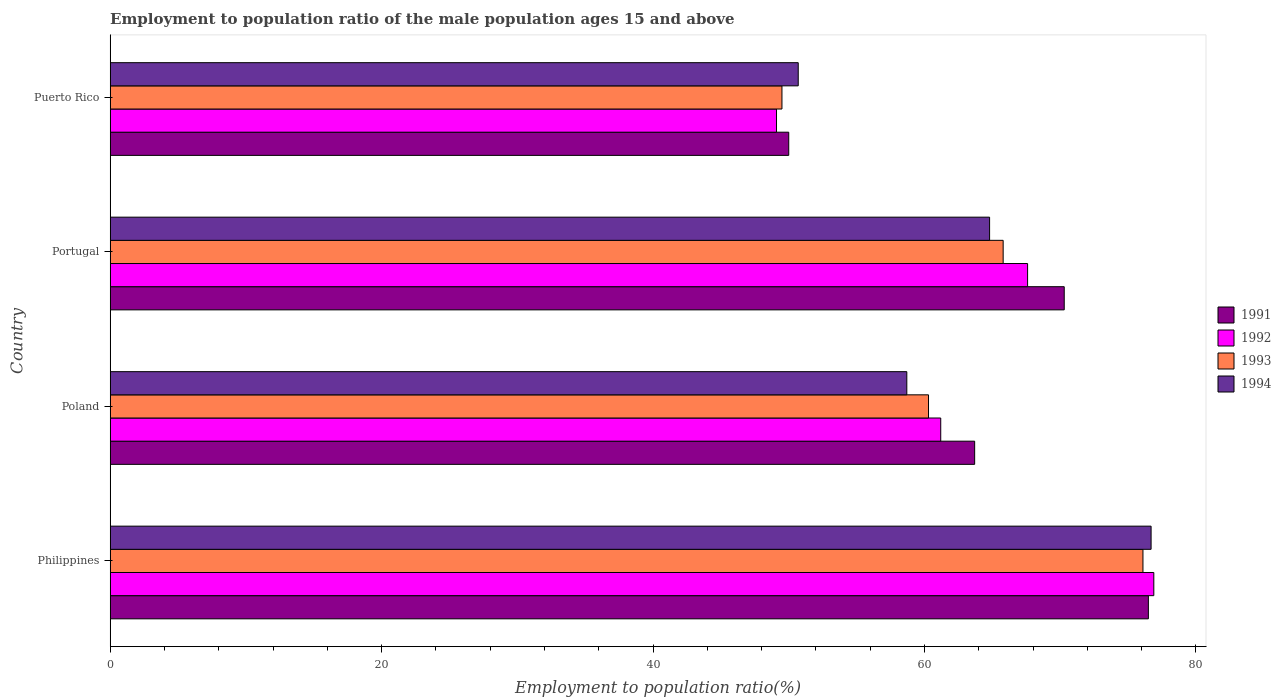Are the number of bars on each tick of the Y-axis equal?
Provide a succinct answer. Yes. In how many cases, is the number of bars for a given country not equal to the number of legend labels?
Offer a terse response. 0. What is the employment to population ratio in 1994 in Poland?
Give a very brief answer. 58.7. Across all countries, what is the maximum employment to population ratio in 1994?
Your response must be concise. 76.7. Across all countries, what is the minimum employment to population ratio in 1992?
Your answer should be compact. 49.1. In which country was the employment to population ratio in 1994 minimum?
Make the answer very short. Puerto Rico. What is the total employment to population ratio in 1992 in the graph?
Provide a short and direct response. 254.8. What is the difference between the employment to population ratio in 1993 in Poland and the employment to population ratio in 1991 in Portugal?
Offer a terse response. -10. What is the average employment to population ratio in 1994 per country?
Give a very brief answer. 62.73. What is the difference between the employment to population ratio in 1992 and employment to population ratio in 1993 in Portugal?
Make the answer very short. 1.8. In how many countries, is the employment to population ratio in 1991 greater than 16 %?
Make the answer very short. 4. What is the ratio of the employment to population ratio in 1994 in Portugal to that in Puerto Rico?
Make the answer very short. 1.28. Is the employment to population ratio in 1991 in Poland less than that in Portugal?
Provide a succinct answer. Yes. What is the difference between the highest and the second highest employment to population ratio in 1992?
Ensure brevity in your answer.  9.3. What is the difference between the highest and the lowest employment to population ratio in 1994?
Provide a short and direct response. 26. In how many countries, is the employment to population ratio in 1991 greater than the average employment to population ratio in 1991 taken over all countries?
Keep it short and to the point. 2. Are all the bars in the graph horizontal?
Give a very brief answer. Yes. How many countries are there in the graph?
Offer a very short reply. 4. What is the difference between two consecutive major ticks on the X-axis?
Provide a short and direct response. 20. Does the graph contain grids?
Your response must be concise. No. Where does the legend appear in the graph?
Give a very brief answer. Center right. How are the legend labels stacked?
Provide a succinct answer. Vertical. What is the title of the graph?
Make the answer very short. Employment to population ratio of the male population ages 15 and above. Does "1969" appear as one of the legend labels in the graph?
Your answer should be compact. No. What is the label or title of the X-axis?
Your answer should be very brief. Employment to population ratio(%). What is the label or title of the Y-axis?
Make the answer very short. Country. What is the Employment to population ratio(%) in 1991 in Philippines?
Provide a short and direct response. 76.5. What is the Employment to population ratio(%) in 1992 in Philippines?
Offer a very short reply. 76.9. What is the Employment to population ratio(%) of 1993 in Philippines?
Make the answer very short. 76.1. What is the Employment to population ratio(%) of 1994 in Philippines?
Ensure brevity in your answer.  76.7. What is the Employment to population ratio(%) of 1991 in Poland?
Your answer should be very brief. 63.7. What is the Employment to population ratio(%) of 1992 in Poland?
Make the answer very short. 61.2. What is the Employment to population ratio(%) of 1993 in Poland?
Your answer should be very brief. 60.3. What is the Employment to population ratio(%) of 1994 in Poland?
Make the answer very short. 58.7. What is the Employment to population ratio(%) of 1991 in Portugal?
Keep it short and to the point. 70.3. What is the Employment to population ratio(%) in 1992 in Portugal?
Your answer should be very brief. 67.6. What is the Employment to population ratio(%) of 1993 in Portugal?
Offer a terse response. 65.8. What is the Employment to population ratio(%) of 1994 in Portugal?
Offer a very short reply. 64.8. What is the Employment to population ratio(%) of 1991 in Puerto Rico?
Ensure brevity in your answer.  50. What is the Employment to population ratio(%) in 1992 in Puerto Rico?
Your answer should be very brief. 49.1. What is the Employment to population ratio(%) of 1993 in Puerto Rico?
Ensure brevity in your answer.  49.5. What is the Employment to population ratio(%) of 1994 in Puerto Rico?
Your response must be concise. 50.7. Across all countries, what is the maximum Employment to population ratio(%) in 1991?
Offer a terse response. 76.5. Across all countries, what is the maximum Employment to population ratio(%) of 1992?
Keep it short and to the point. 76.9. Across all countries, what is the maximum Employment to population ratio(%) in 1993?
Your answer should be very brief. 76.1. Across all countries, what is the maximum Employment to population ratio(%) in 1994?
Provide a succinct answer. 76.7. Across all countries, what is the minimum Employment to population ratio(%) of 1991?
Make the answer very short. 50. Across all countries, what is the minimum Employment to population ratio(%) in 1992?
Your answer should be very brief. 49.1. Across all countries, what is the minimum Employment to population ratio(%) of 1993?
Give a very brief answer. 49.5. Across all countries, what is the minimum Employment to population ratio(%) in 1994?
Your response must be concise. 50.7. What is the total Employment to population ratio(%) in 1991 in the graph?
Your answer should be very brief. 260.5. What is the total Employment to population ratio(%) of 1992 in the graph?
Your answer should be compact. 254.8. What is the total Employment to population ratio(%) in 1993 in the graph?
Provide a short and direct response. 251.7. What is the total Employment to population ratio(%) in 1994 in the graph?
Your response must be concise. 250.9. What is the difference between the Employment to population ratio(%) of 1993 in Philippines and that in Poland?
Keep it short and to the point. 15.8. What is the difference between the Employment to population ratio(%) of 1993 in Philippines and that in Portugal?
Provide a succinct answer. 10.3. What is the difference between the Employment to population ratio(%) of 1992 in Philippines and that in Puerto Rico?
Your response must be concise. 27.8. What is the difference between the Employment to population ratio(%) in 1993 in Philippines and that in Puerto Rico?
Your answer should be compact. 26.6. What is the difference between the Employment to population ratio(%) of 1992 in Poland and that in Portugal?
Offer a terse response. -6.4. What is the difference between the Employment to population ratio(%) in 1993 in Poland and that in Portugal?
Offer a very short reply. -5.5. What is the difference between the Employment to population ratio(%) in 1992 in Poland and that in Puerto Rico?
Offer a terse response. 12.1. What is the difference between the Employment to population ratio(%) of 1994 in Poland and that in Puerto Rico?
Your answer should be compact. 8. What is the difference between the Employment to population ratio(%) in 1991 in Portugal and that in Puerto Rico?
Keep it short and to the point. 20.3. What is the difference between the Employment to population ratio(%) in 1992 in Portugal and that in Puerto Rico?
Offer a terse response. 18.5. What is the difference between the Employment to population ratio(%) of 1993 in Portugal and that in Puerto Rico?
Make the answer very short. 16.3. What is the difference between the Employment to population ratio(%) of 1994 in Portugal and that in Puerto Rico?
Offer a very short reply. 14.1. What is the difference between the Employment to population ratio(%) in 1991 in Philippines and the Employment to population ratio(%) in 1993 in Poland?
Offer a terse response. 16.2. What is the difference between the Employment to population ratio(%) in 1991 in Philippines and the Employment to population ratio(%) in 1994 in Poland?
Your response must be concise. 17.8. What is the difference between the Employment to population ratio(%) in 1992 in Philippines and the Employment to population ratio(%) in 1994 in Poland?
Make the answer very short. 18.2. What is the difference between the Employment to population ratio(%) in 1991 in Philippines and the Employment to population ratio(%) in 1992 in Portugal?
Offer a very short reply. 8.9. What is the difference between the Employment to population ratio(%) in 1991 in Philippines and the Employment to population ratio(%) in 1993 in Portugal?
Keep it short and to the point. 10.7. What is the difference between the Employment to population ratio(%) in 1991 in Philippines and the Employment to population ratio(%) in 1994 in Portugal?
Your answer should be very brief. 11.7. What is the difference between the Employment to population ratio(%) in 1991 in Philippines and the Employment to population ratio(%) in 1992 in Puerto Rico?
Offer a very short reply. 27.4. What is the difference between the Employment to population ratio(%) in 1991 in Philippines and the Employment to population ratio(%) in 1994 in Puerto Rico?
Provide a succinct answer. 25.8. What is the difference between the Employment to population ratio(%) of 1992 in Philippines and the Employment to population ratio(%) of 1993 in Puerto Rico?
Ensure brevity in your answer.  27.4. What is the difference between the Employment to population ratio(%) in 1992 in Philippines and the Employment to population ratio(%) in 1994 in Puerto Rico?
Your answer should be compact. 26.2. What is the difference between the Employment to population ratio(%) of 1993 in Philippines and the Employment to population ratio(%) of 1994 in Puerto Rico?
Keep it short and to the point. 25.4. What is the difference between the Employment to population ratio(%) of 1991 in Poland and the Employment to population ratio(%) of 1992 in Portugal?
Make the answer very short. -3.9. What is the difference between the Employment to population ratio(%) of 1991 in Poland and the Employment to population ratio(%) of 1993 in Portugal?
Give a very brief answer. -2.1. What is the difference between the Employment to population ratio(%) in 1992 in Poland and the Employment to population ratio(%) in 1993 in Portugal?
Your answer should be very brief. -4.6. What is the difference between the Employment to population ratio(%) of 1992 in Poland and the Employment to population ratio(%) of 1994 in Portugal?
Make the answer very short. -3.6. What is the difference between the Employment to population ratio(%) in 1991 in Poland and the Employment to population ratio(%) in 1992 in Puerto Rico?
Ensure brevity in your answer.  14.6. What is the difference between the Employment to population ratio(%) of 1991 in Poland and the Employment to population ratio(%) of 1993 in Puerto Rico?
Give a very brief answer. 14.2. What is the difference between the Employment to population ratio(%) in 1993 in Poland and the Employment to population ratio(%) in 1994 in Puerto Rico?
Your response must be concise. 9.6. What is the difference between the Employment to population ratio(%) of 1991 in Portugal and the Employment to population ratio(%) of 1992 in Puerto Rico?
Keep it short and to the point. 21.2. What is the difference between the Employment to population ratio(%) of 1991 in Portugal and the Employment to population ratio(%) of 1993 in Puerto Rico?
Your response must be concise. 20.8. What is the difference between the Employment to population ratio(%) in 1991 in Portugal and the Employment to population ratio(%) in 1994 in Puerto Rico?
Ensure brevity in your answer.  19.6. What is the average Employment to population ratio(%) of 1991 per country?
Your answer should be compact. 65.12. What is the average Employment to population ratio(%) of 1992 per country?
Offer a very short reply. 63.7. What is the average Employment to population ratio(%) of 1993 per country?
Make the answer very short. 62.92. What is the average Employment to population ratio(%) in 1994 per country?
Offer a very short reply. 62.73. What is the difference between the Employment to population ratio(%) of 1992 and Employment to population ratio(%) of 1994 in Philippines?
Your answer should be compact. 0.2. What is the difference between the Employment to population ratio(%) of 1991 and Employment to population ratio(%) of 1994 in Poland?
Provide a short and direct response. 5. What is the difference between the Employment to population ratio(%) of 1992 and Employment to population ratio(%) of 1994 in Poland?
Make the answer very short. 2.5. What is the difference between the Employment to population ratio(%) of 1993 and Employment to population ratio(%) of 1994 in Poland?
Offer a terse response. 1.6. What is the difference between the Employment to population ratio(%) of 1991 and Employment to population ratio(%) of 1992 in Portugal?
Ensure brevity in your answer.  2.7. What is the ratio of the Employment to population ratio(%) in 1991 in Philippines to that in Poland?
Make the answer very short. 1.2. What is the ratio of the Employment to population ratio(%) in 1992 in Philippines to that in Poland?
Make the answer very short. 1.26. What is the ratio of the Employment to population ratio(%) in 1993 in Philippines to that in Poland?
Offer a terse response. 1.26. What is the ratio of the Employment to population ratio(%) of 1994 in Philippines to that in Poland?
Your answer should be very brief. 1.31. What is the ratio of the Employment to population ratio(%) in 1991 in Philippines to that in Portugal?
Make the answer very short. 1.09. What is the ratio of the Employment to population ratio(%) of 1992 in Philippines to that in Portugal?
Your answer should be compact. 1.14. What is the ratio of the Employment to population ratio(%) in 1993 in Philippines to that in Portugal?
Your response must be concise. 1.16. What is the ratio of the Employment to population ratio(%) of 1994 in Philippines to that in Portugal?
Keep it short and to the point. 1.18. What is the ratio of the Employment to population ratio(%) of 1991 in Philippines to that in Puerto Rico?
Your response must be concise. 1.53. What is the ratio of the Employment to population ratio(%) of 1992 in Philippines to that in Puerto Rico?
Give a very brief answer. 1.57. What is the ratio of the Employment to population ratio(%) in 1993 in Philippines to that in Puerto Rico?
Ensure brevity in your answer.  1.54. What is the ratio of the Employment to population ratio(%) in 1994 in Philippines to that in Puerto Rico?
Provide a succinct answer. 1.51. What is the ratio of the Employment to population ratio(%) of 1991 in Poland to that in Portugal?
Offer a terse response. 0.91. What is the ratio of the Employment to population ratio(%) in 1992 in Poland to that in Portugal?
Your answer should be compact. 0.91. What is the ratio of the Employment to population ratio(%) of 1993 in Poland to that in Portugal?
Provide a succinct answer. 0.92. What is the ratio of the Employment to population ratio(%) of 1994 in Poland to that in Portugal?
Provide a succinct answer. 0.91. What is the ratio of the Employment to population ratio(%) in 1991 in Poland to that in Puerto Rico?
Your response must be concise. 1.27. What is the ratio of the Employment to population ratio(%) in 1992 in Poland to that in Puerto Rico?
Offer a terse response. 1.25. What is the ratio of the Employment to population ratio(%) of 1993 in Poland to that in Puerto Rico?
Provide a short and direct response. 1.22. What is the ratio of the Employment to population ratio(%) of 1994 in Poland to that in Puerto Rico?
Offer a very short reply. 1.16. What is the ratio of the Employment to population ratio(%) of 1991 in Portugal to that in Puerto Rico?
Provide a short and direct response. 1.41. What is the ratio of the Employment to population ratio(%) of 1992 in Portugal to that in Puerto Rico?
Provide a short and direct response. 1.38. What is the ratio of the Employment to population ratio(%) in 1993 in Portugal to that in Puerto Rico?
Offer a very short reply. 1.33. What is the ratio of the Employment to population ratio(%) in 1994 in Portugal to that in Puerto Rico?
Ensure brevity in your answer.  1.28. What is the difference between the highest and the second highest Employment to population ratio(%) in 1992?
Keep it short and to the point. 9.3. What is the difference between the highest and the second highest Employment to population ratio(%) of 1993?
Offer a terse response. 10.3. What is the difference between the highest and the second highest Employment to population ratio(%) in 1994?
Ensure brevity in your answer.  11.9. What is the difference between the highest and the lowest Employment to population ratio(%) of 1992?
Keep it short and to the point. 27.8. What is the difference between the highest and the lowest Employment to population ratio(%) of 1993?
Provide a short and direct response. 26.6. What is the difference between the highest and the lowest Employment to population ratio(%) of 1994?
Provide a succinct answer. 26. 